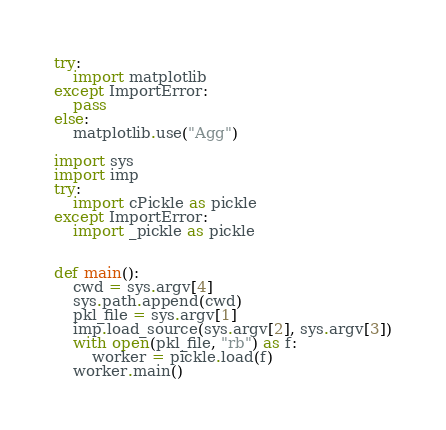Convert code to text. <code><loc_0><loc_0><loc_500><loc_500><_Python_>try:
    import matplotlib
except ImportError:
    pass
else:
    matplotlib.use("Agg")

import sys
import imp
try:
    import cPickle as pickle
except ImportError:
    import _pickle as pickle


def main():
    cwd = sys.argv[4]
    sys.path.append(cwd)
    pkl_file = sys.argv[1]
    imp.load_source(sys.argv[2], sys.argv[3])
    with open(pkl_file, "rb") as f:
        worker = pickle.load(f)
    worker.main()
</code> 